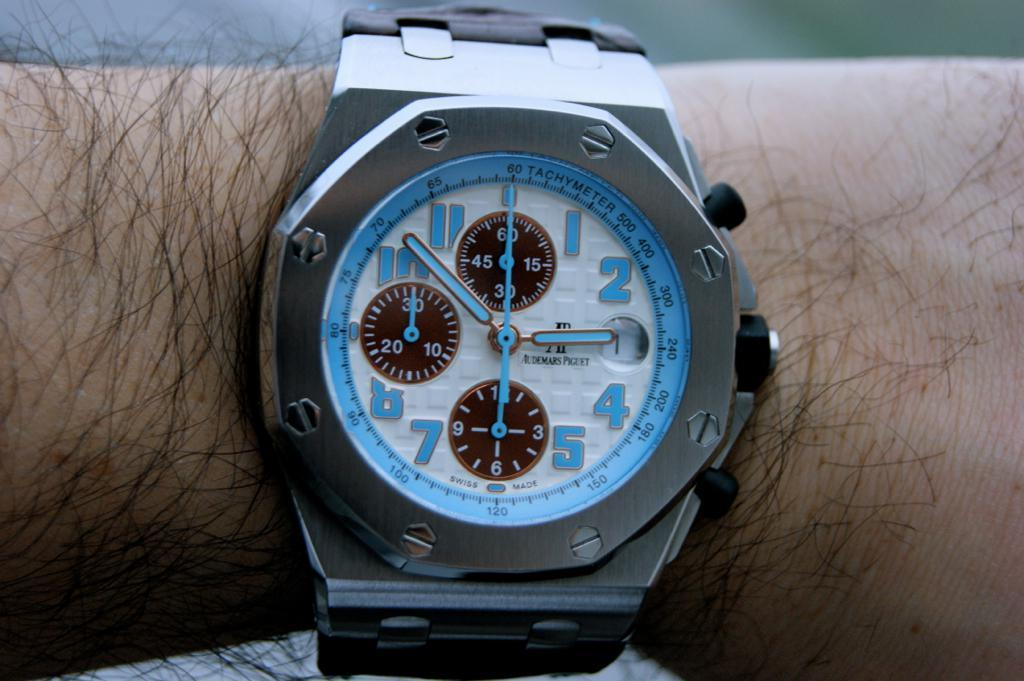<image>
Share a concise interpretation of the image provided. A man with a slightly hairy arm is wearing a blue and silver, Audemars Piguet wrist watch that has the time 2:52. 